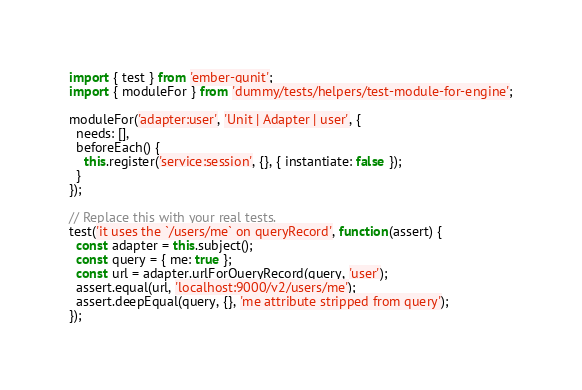Convert code to text. <code><loc_0><loc_0><loc_500><loc_500><_JavaScript_>import { test } from 'ember-qunit';
import { moduleFor } from 'dummy/tests/helpers/test-module-for-engine';

moduleFor('adapter:user', 'Unit | Adapter | user', {
  needs: [],
  beforeEach() {
    this.register('service:session', {}, { instantiate: false });
  }
});

// Replace this with your real tests.
test('it uses the `/users/me` on queryRecord', function(assert) {
  const adapter = this.subject();
  const query = { me: true };
  const url = adapter.urlForQueryRecord(query, 'user');
  assert.equal(url, 'localhost:9000/v2/users/me');
  assert.deepEqual(query, {}, 'me attribute stripped from query');
});
</code> 